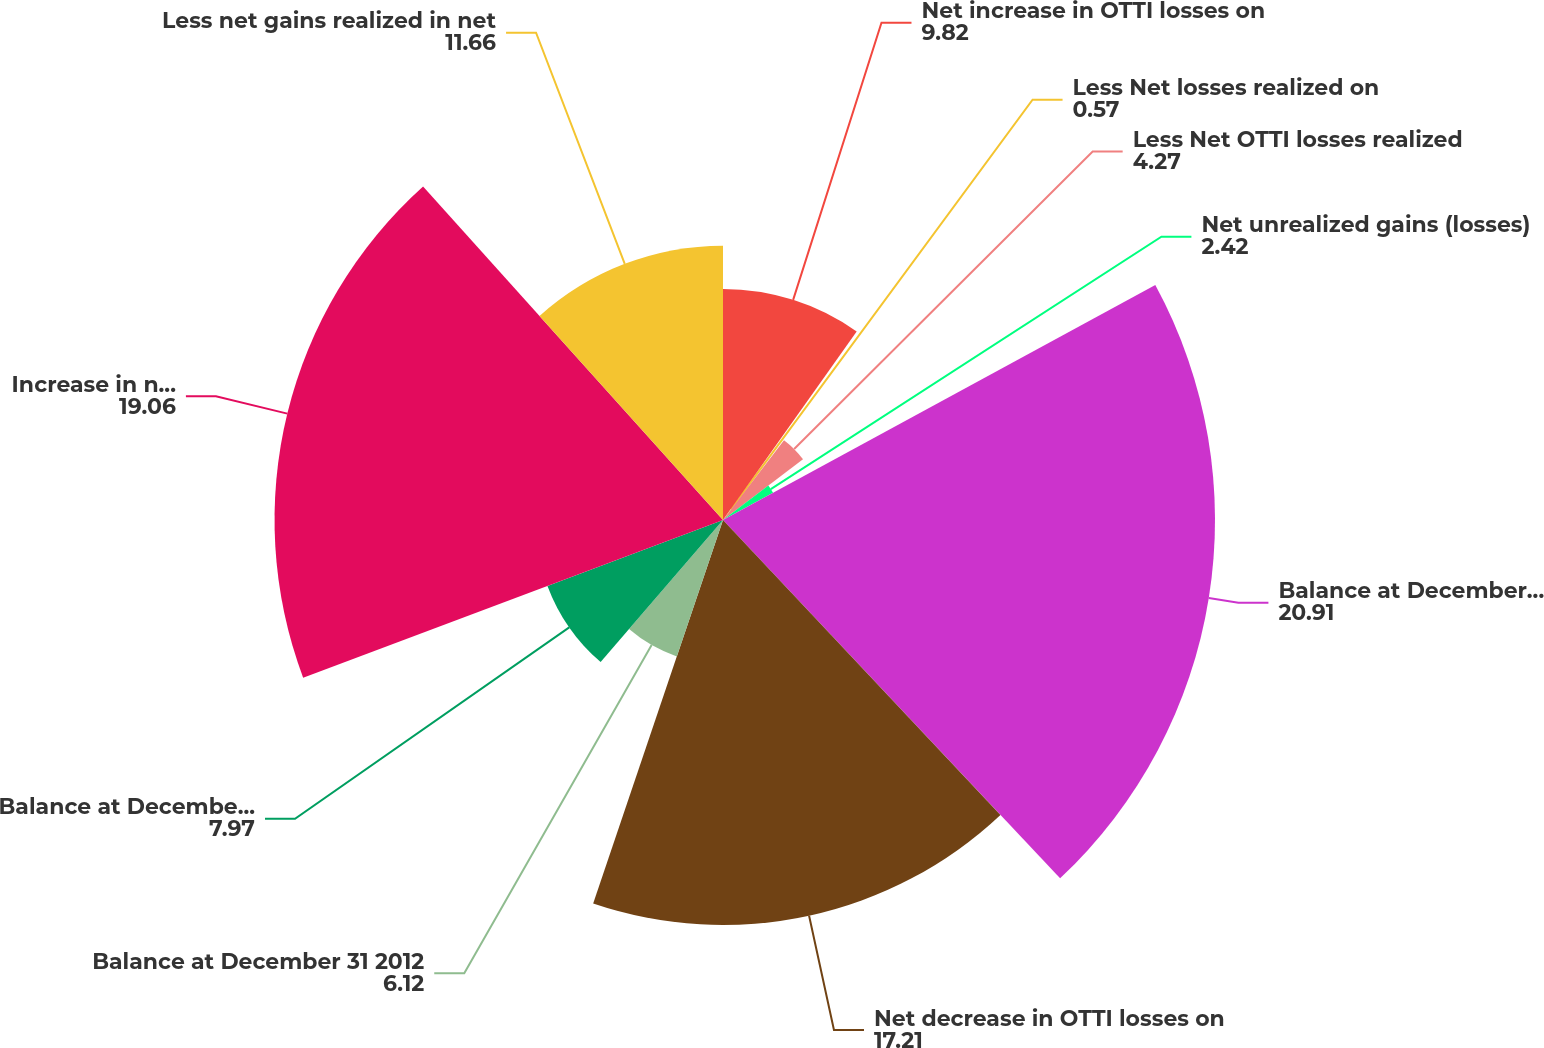Convert chart to OTSL. <chart><loc_0><loc_0><loc_500><loc_500><pie_chart><fcel>Net increase in OTTI losses on<fcel>Less Net losses realized on<fcel>Less Net OTTI losses realized<fcel>Net unrealized gains (losses)<fcel>Balance at December 31 2011<fcel>Net decrease in OTTI losses on<fcel>Balance at December 31 2012<fcel>Balance at December 31 2009<fcel>Increase in net unrealized<fcel>Less net gains realized in net<nl><fcel>9.82%<fcel>0.57%<fcel>4.27%<fcel>2.42%<fcel>20.91%<fcel>17.21%<fcel>6.12%<fcel>7.97%<fcel>19.06%<fcel>11.66%<nl></chart> 